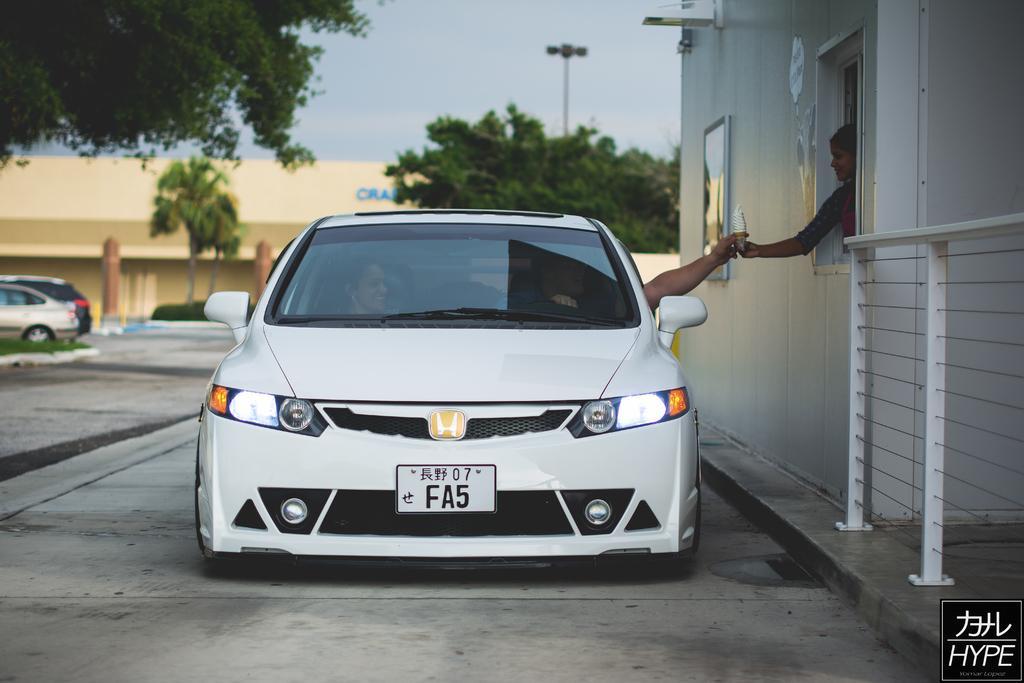How would you summarize this image in a sentence or two? In this picture we can see a woman in the shop is giving an ice cream to a man sitting in the car. We can see a person sitting in the car. There are few vehicles on the left side. We can see some trees, buildings and a streetlight in the background. A watermark is visible on bottom right. 